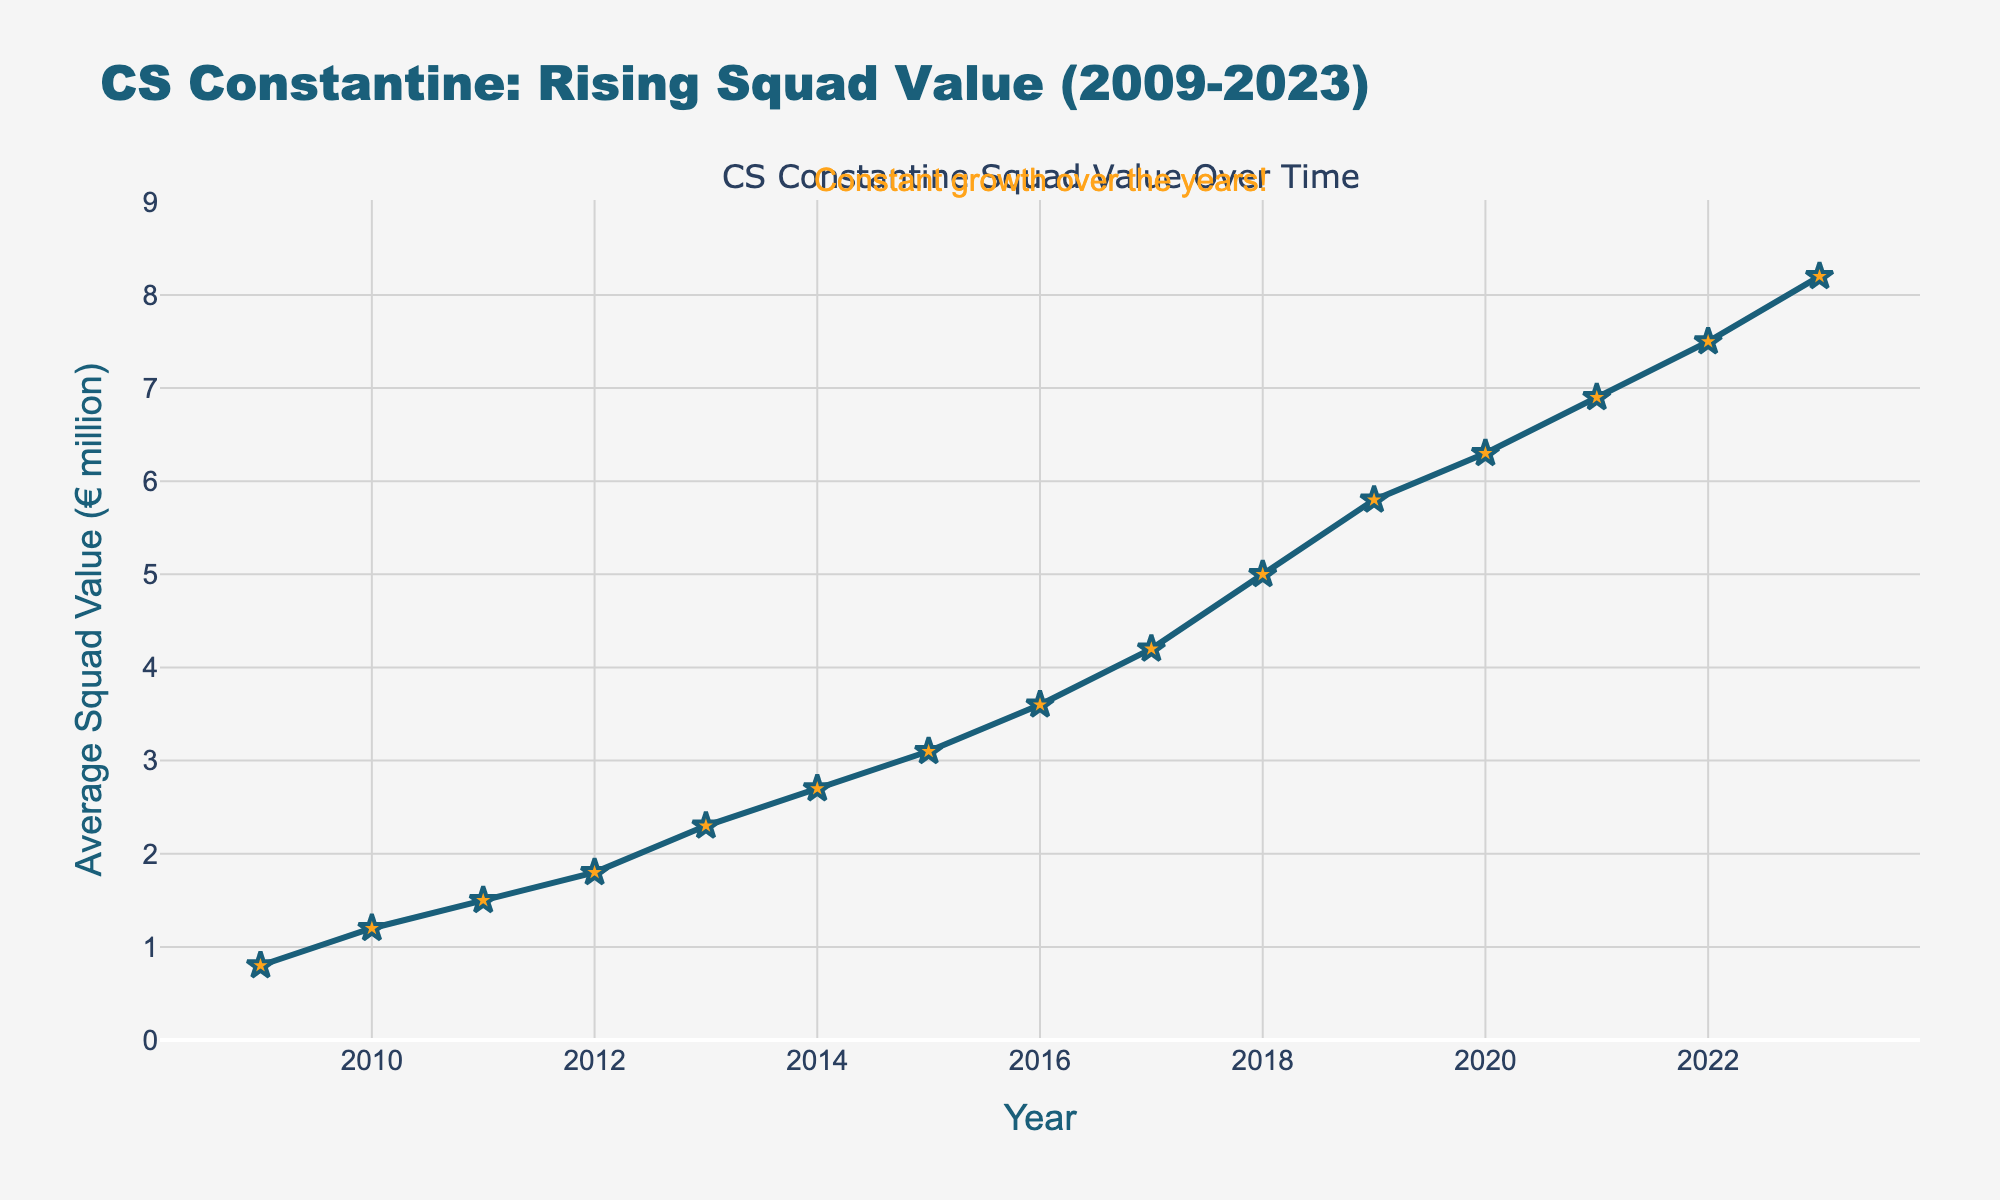What's the range of average squad values from 2009 to 2023? To find the range, subtract the minimum value from the maximum value. The minimum value is 0.8 million in 2009, and the maximum value is 8.2 million in 2023. So, the range is 8.2 - 0.8 = 7.4 million.
Answer: 7.4 million Which year had the highest average squad value? The highest average squad value of 8.2 million appears in the year 2023.
Answer: 2023 In which year did CS Constantine's average squad value first exceed 5 million euros? The squad value first exceeded 5 million euros in 2018, where it reached 5.0 million.
Answer: 2018 By how much did the average squad value increase from 2015 to 2020? The average squad value in 2015 was 3.1 million, and in 2020 it was 6.3 million. The increase is 6.3 - 3.1 = 3.2 million.
Answer: 3.2 million What is the median average squad value over the 15 years? To find the median, the values should be ordered: 0.8, 1.2, 1.5, 1.8, 2.3, 2.7, 3.1, 3.6, 4.2, 5.0, 5.8, 6.3, 6.9, 7.5, 8.2. The median is the middle value, which is 3.6 million.
Answer: 3.6 million During which period was the growth in average squad value the fastest? Calculate the yearly growth rate and compare them. The fastest growth rate is from 2017 (4.2 million) to 2018 (5.0 million), with a growth of 5.0 - 4.2 = 0.8 million.
Answer: 2017-2018 Which year shows a marker that is visually different from the rest? The markers are all similar but the star-shaped markers with a larger size are notable and consistently used throughout.
Answer: None (all markers are the same) How much did the average squad value change from 2012 to 2013, and was it an increase or a decrease? The average squad value in 2012 was 1.8 million, and in 2013 it was 2.3 million. The change is 2.3 - 1.8 = 0.5 million, which is an increase.
Answer: 0.5 million increase What's the average annual growth in squad value over the entire period? To find the average annual growth, sum up the yearly increase from 2009 to 2023 and divide by the number of years. Total increase = 8.2 - 0.8 = 7.4 million over 14 years, so average growth = 7.4 / 14 ≈ 0.53 million per year.
Answer: 0.53 million per year 